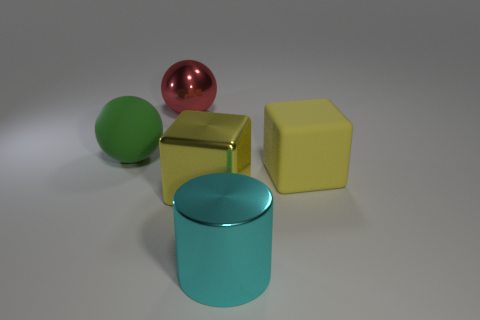What material is the other block that is the same color as the matte cube?
Your response must be concise. Metal. What color is the metallic sphere?
Make the answer very short. Red. What is the color of the sphere that is left of the sphere to the right of the rubber sphere that is behind the big cylinder?
Ensure brevity in your answer.  Green. There is a large red metal thing; is its shape the same as the rubber object that is right of the red shiny ball?
Offer a very short reply. No. What color is the thing that is in front of the large green sphere and on the left side of the cyan cylinder?
Ensure brevity in your answer.  Yellow. Are there any other large things of the same shape as the red thing?
Your answer should be very brief. Yes. Does the large rubber cube have the same color as the cylinder?
Your response must be concise. No. There is a rubber object on the left side of the big red ball; is there a green sphere that is on the left side of it?
Offer a terse response. No. What number of objects are objects that are in front of the large yellow rubber object or big cubes in front of the green matte object?
Keep it short and to the point. 3. How many things are either red things or things that are on the right side of the rubber ball?
Make the answer very short. 4. 